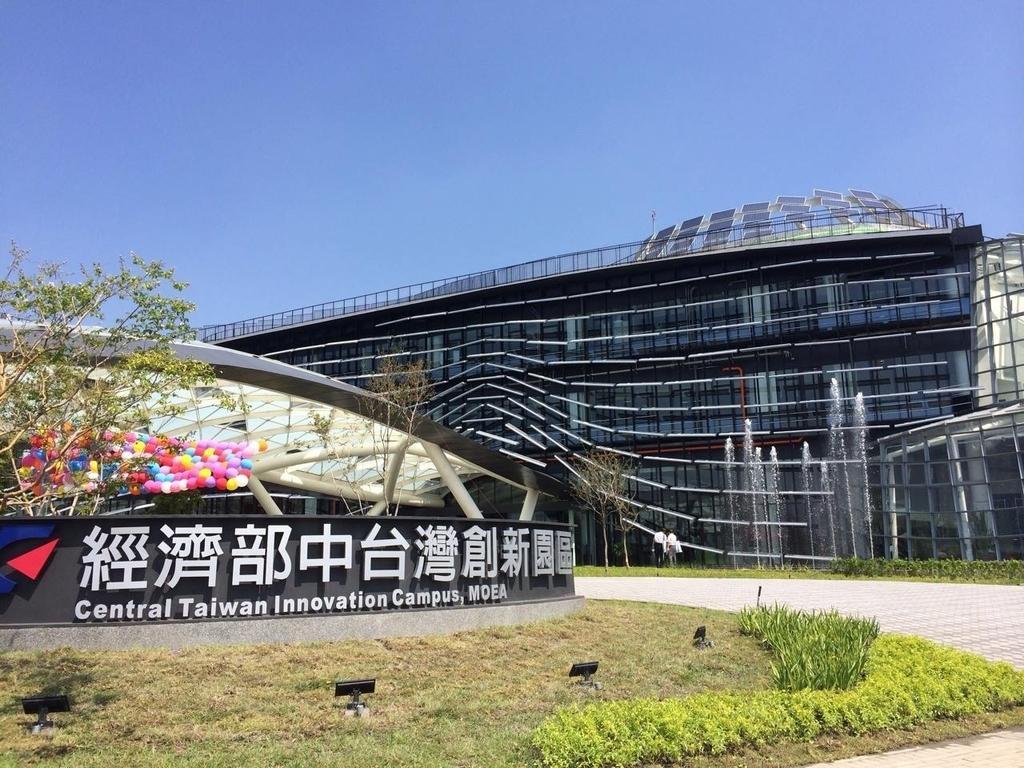Can you describe this image briefly? In the picture I can see buildings and people standing on the ground. I can see a road, the grass and plants. On the left side I can see trees, lights and some names over here. In the background I can see the sky. 